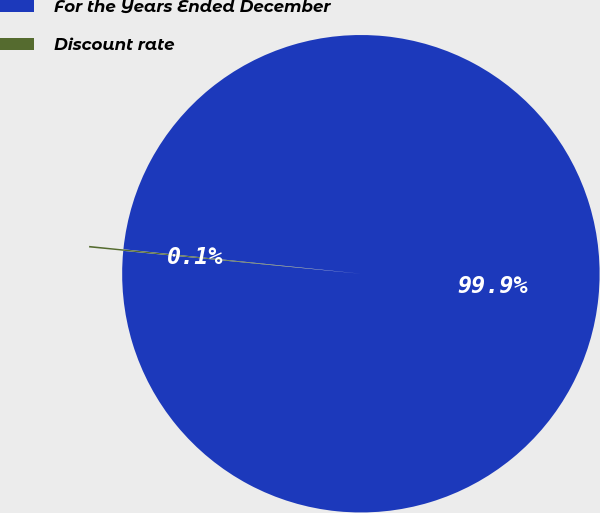<chart> <loc_0><loc_0><loc_500><loc_500><pie_chart><fcel>For the Years Ended December<fcel>Discount rate<nl><fcel>99.89%<fcel>0.11%<nl></chart> 